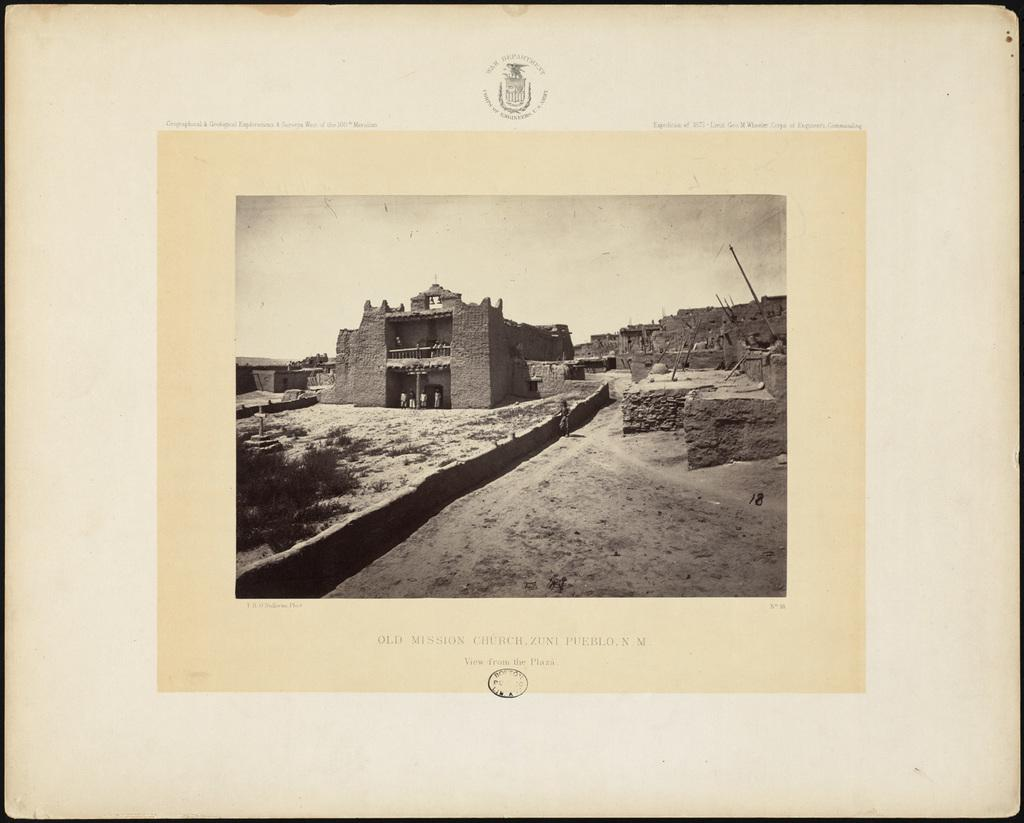<image>
Summarize the visual content of the image. An old photo that depicts Old Mission Church in Zuni Pueblo New Mexico. 